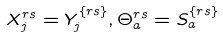Convert formula to latex. <formula><loc_0><loc_0><loc_500><loc_500>X _ { j } ^ { r s } = Y _ { j } ^ { \{ r s \} } , \Theta _ { a } ^ { r s } = S _ { a } ^ { \{ r s \} }</formula> 